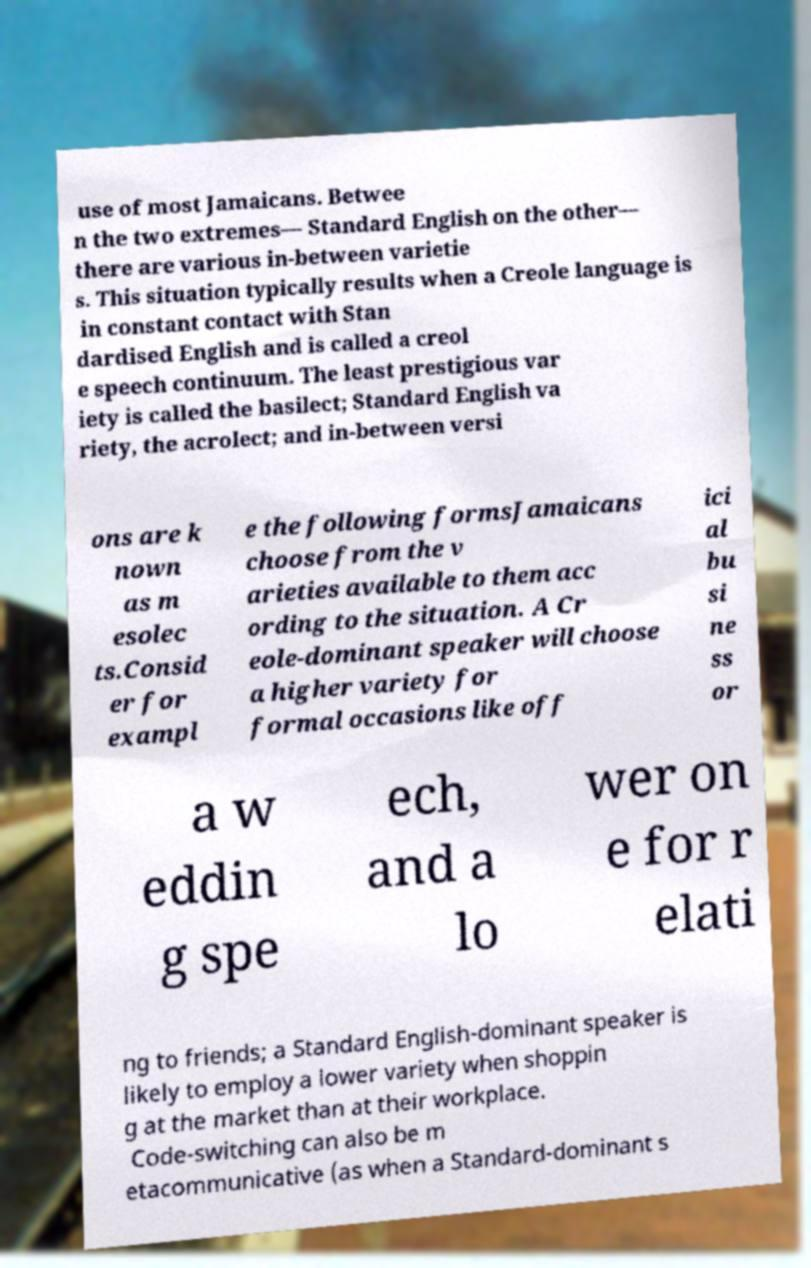I need the written content from this picture converted into text. Can you do that? use of most Jamaicans. Betwee n the two extremes— Standard English on the other— there are various in-between varietie s. This situation typically results when a Creole language is in constant contact with Stan dardised English and is called a creol e speech continuum. The least prestigious var iety is called the basilect; Standard English va riety, the acrolect; and in-between versi ons are k nown as m esolec ts.Consid er for exampl e the following formsJamaicans choose from the v arieties available to them acc ording to the situation. A Cr eole-dominant speaker will choose a higher variety for formal occasions like off ici al bu si ne ss or a w eddin g spe ech, and a lo wer on e for r elati ng to friends; a Standard English-dominant speaker is likely to employ a lower variety when shoppin g at the market than at their workplace. Code-switching can also be m etacommunicative (as when a Standard-dominant s 